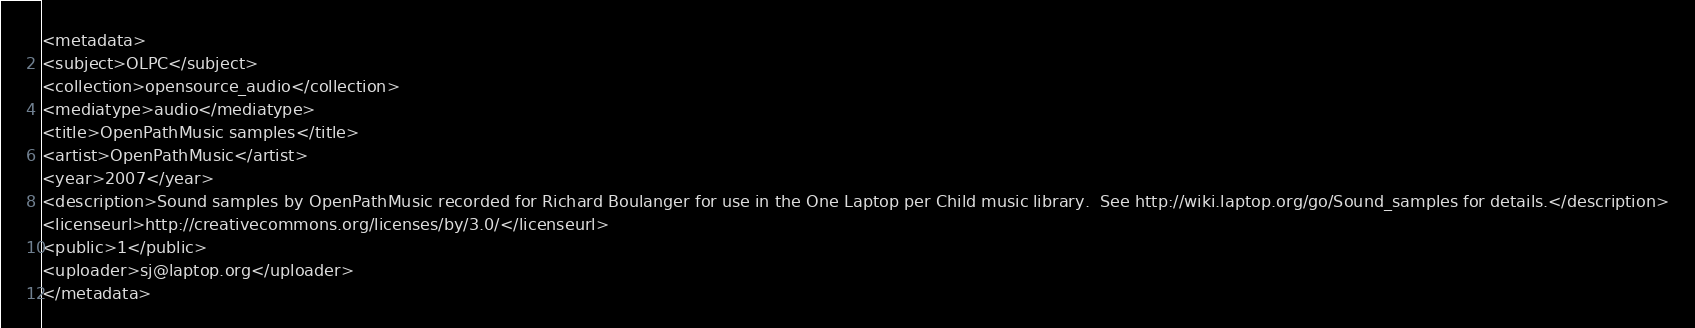<code> <loc_0><loc_0><loc_500><loc_500><_XML_><metadata>
<subject>OLPC</subject>
<collection>opensource_audio</collection>
<mediatype>audio</mediatype>
<title>OpenPathMusic samples</title>
<artist>OpenPathMusic</artist>
<year>2007</year>
<description>Sound samples by OpenPathMusic recorded for Richard Boulanger for use in the One Laptop per Child music library.  See http://wiki.laptop.org/go/Sound_samples for details.</description>
<licenseurl>http://creativecommons.org/licenses/by/3.0/</licenseurl>
<public>1</public>
<uploader>sj@laptop.org</uploader>
</metadata>
</code> 